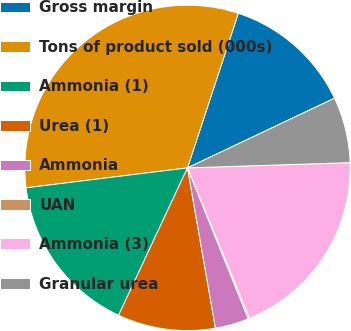Convert chart to OTSL. <chart><loc_0><loc_0><loc_500><loc_500><pie_chart><fcel>Gross margin<fcel>Tons of product sold (000s)<fcel>Ammonia (1)<fcel>Urea (1)<fcel>Ammonia<fcel>UAN<fcel>Ammonia (3)<fcel>Granular urea<nl><fcel>12.9%<fcel>32.01%<fcel>16.08%<fcel>9.71%<fcel>3.34%<fcel>0.15%<fcel>19.27%<fcel>6.53%<nl></chart> 